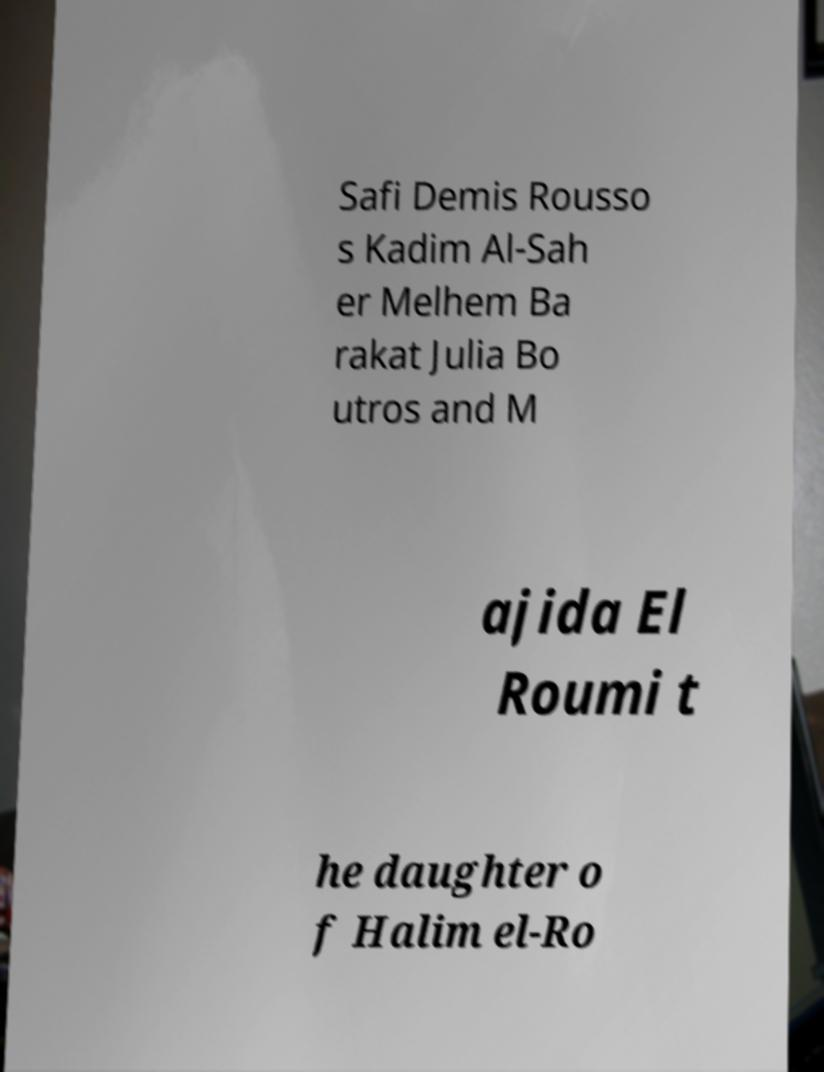Could you extract and type out the text from this image? Safi Demis Rousso s Kadim Al-Sah er Melhem Ba rakat Julia Bo utros and M ajida El Roumi t he daughter o f Halim el-Ro 